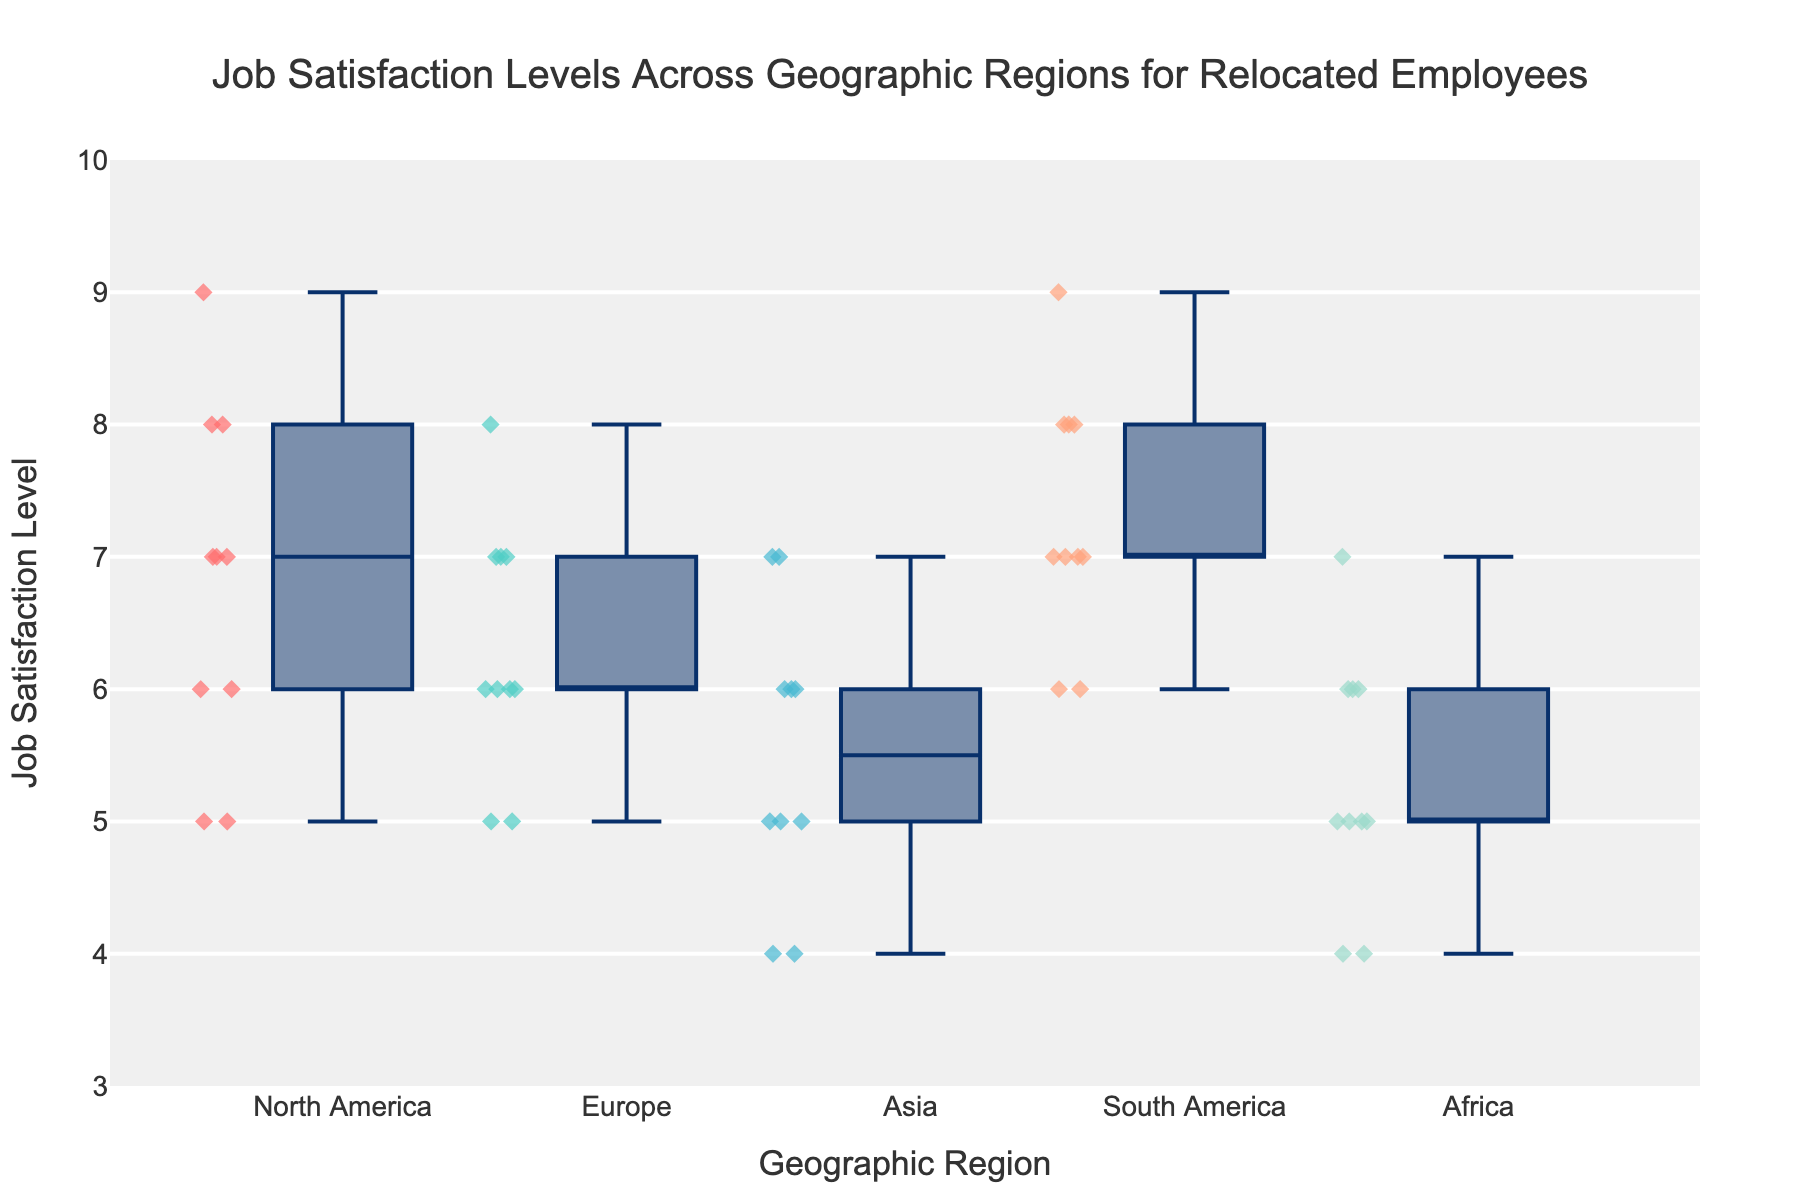What is the title of the figure? The title is usually displayed at the top of the plot, and in this case, it reads: "Job Satisfaction Levels Across Geographic Regions for Relocated Employees."
Answer: Job Satisfaction Levels Across Geographic Regions for Relocated Employees What are the geographic regions listed on the x-axis? The x-axis shows different categories representing regions. From the box plot, the regions are North America, Europe, Asia, South America, and Africa.
Answer: North America, Europe, Asia, South America, and Africa Which region has the highest median job satisfaction level? The median job satisfaction level is represented by the line inside each box. By visual inspection, the region with the highest median job satisfaction level is South America.
Answer: South America Which region appears to have the most variability in job satisfaction levels? The variability of job satisfaction levels can be observed by the length of the box and the whiskers. Asia seems to have the longest box and whiskers, indicating the highest variability.
Answer: Asia How many outliers are there in the North America region, and what are their values? Outliers are usually marked by individual points outside the whiskers. In North America, there are two outliers with values at the points above and below the whiskers. The values can be seen at 9 and 5.
Answer: 2 (values: 5 and 9) Which region has the lowest lowest job satisfaction level? The lowest job satisfaction levels are indicated by the bottom end of the whiskers for each region. By examining the plot, we see that Asia has the lowest, at 4.
Answer: Asia How does the median job satisfaction level in Europe compare to that in North America? The median job satisfaction level is the line inside the box. Both Europe and North America have medians at 6.
Answer: Equal Which regions have job satisfaction levels that do not overlap at all with each other? Non-overlapping box plots indicate different ranges of job satisfaction levels. By looking at the plot, South America and Africa do not overlap with any other regions.
Answer: South America and Africa 